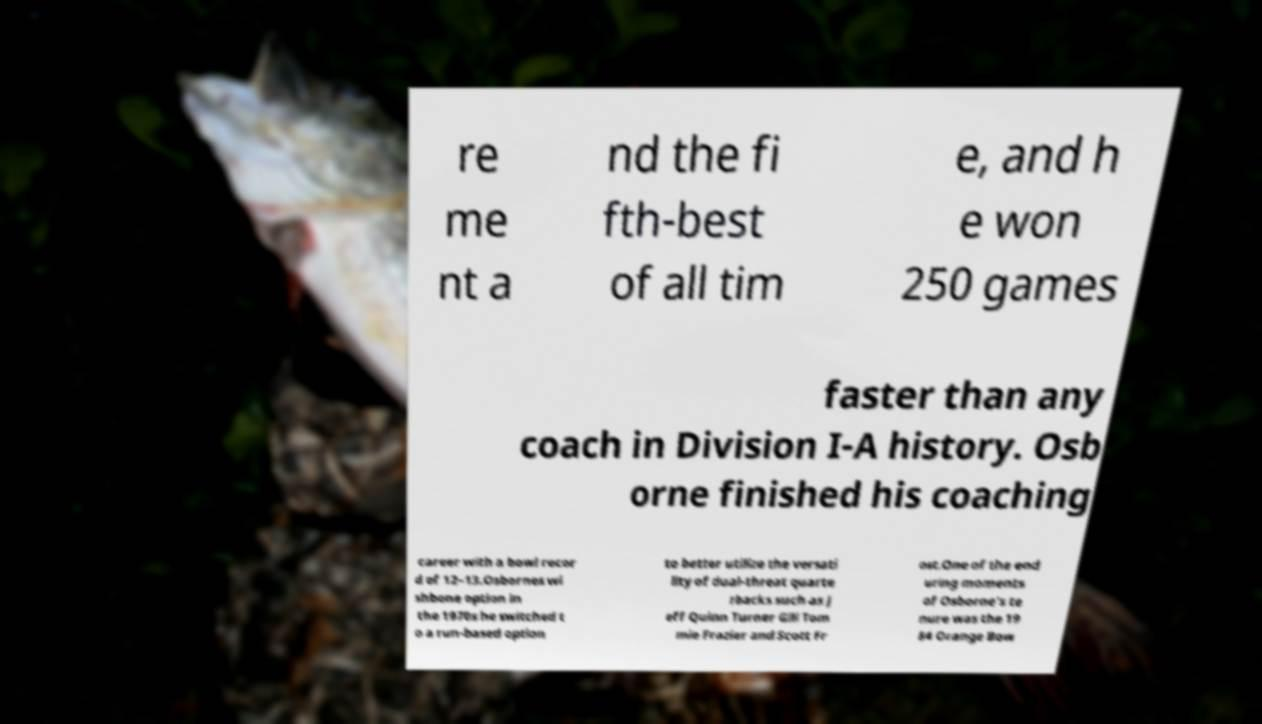I need the written content from this picture converted into text. Can you do that? re me nt a nd the fi fth-best of all tim e, and h e won 250 games faster than any coach in Division I-A history. Osb orne finished his coaching career with a bowl recor d of 12–13.Osbornes wi shbone option in the 1970s he switched t o a run-based option to better utilize the versati lity of dual-threat quarte rbacks such as J eff Quinn Turner Gill Tom mie Frazier and Scott Fr ost.One of the end uring moments of Osborne's te nure was the 19 84 Orange Bow 